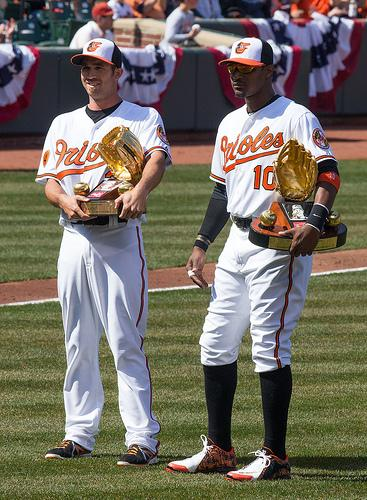Mention the type of trophy obtained by the baseball players in the image. The baseball players are holding large trophies made of a golden catcher's mitt, symbolizing great accomplishment in the sport. Discuss the unique aspects of one person's clothing and accessories. A man is wearing white pants with a red stripe, a black belt, long black socks, sunglasses, and a hat with an orange, black, and white color scheme. Examine the image and describe one unusual object or accessory present. An intriguing accessory in the image is a man's wristband, visible on his left hand, which could signify a personal style choice or a functional use during gameplay. Can you list different noticeable footwear in the image with its characteristics? 2. White, orange, and black sneakers with yellow laces - worn by another man Describe the location where the image takes place and its features. The image takes place on a green grass baseball field with white markings and some spectators watching from behind a fence. Analyze the color and design of the cap worn by a person in the image. The cap worn by a person in the image is orange, black, and white in color, likely representing a team's colors or a brand logo. Quantify the number of people in the image and describe their actions. There are two baseball players interacting with each other and holding trophies, while other people sit and watch the event from behind a fence. What number is visible on a t-shirt in the image, and what might it signify? The number 10 is visible on a t-shirt, which could signify the player's jersey number or team position. What kind of award is visible in the image? Elaborate. A golden glove award is visible, which is a trophy with a golden catcher's mitt on it, symbolizing high achievement in baseball. Identify and describe the sunglasses worn by a person in the image. A baseball player is wearing sunglasses with yellow lenses that cover a significant portion of his face. 